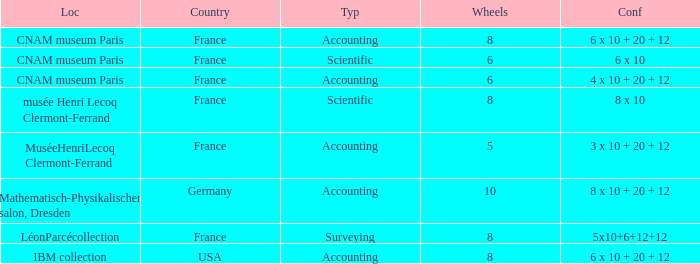What location has surveying as the type? LéonParcécollection. 